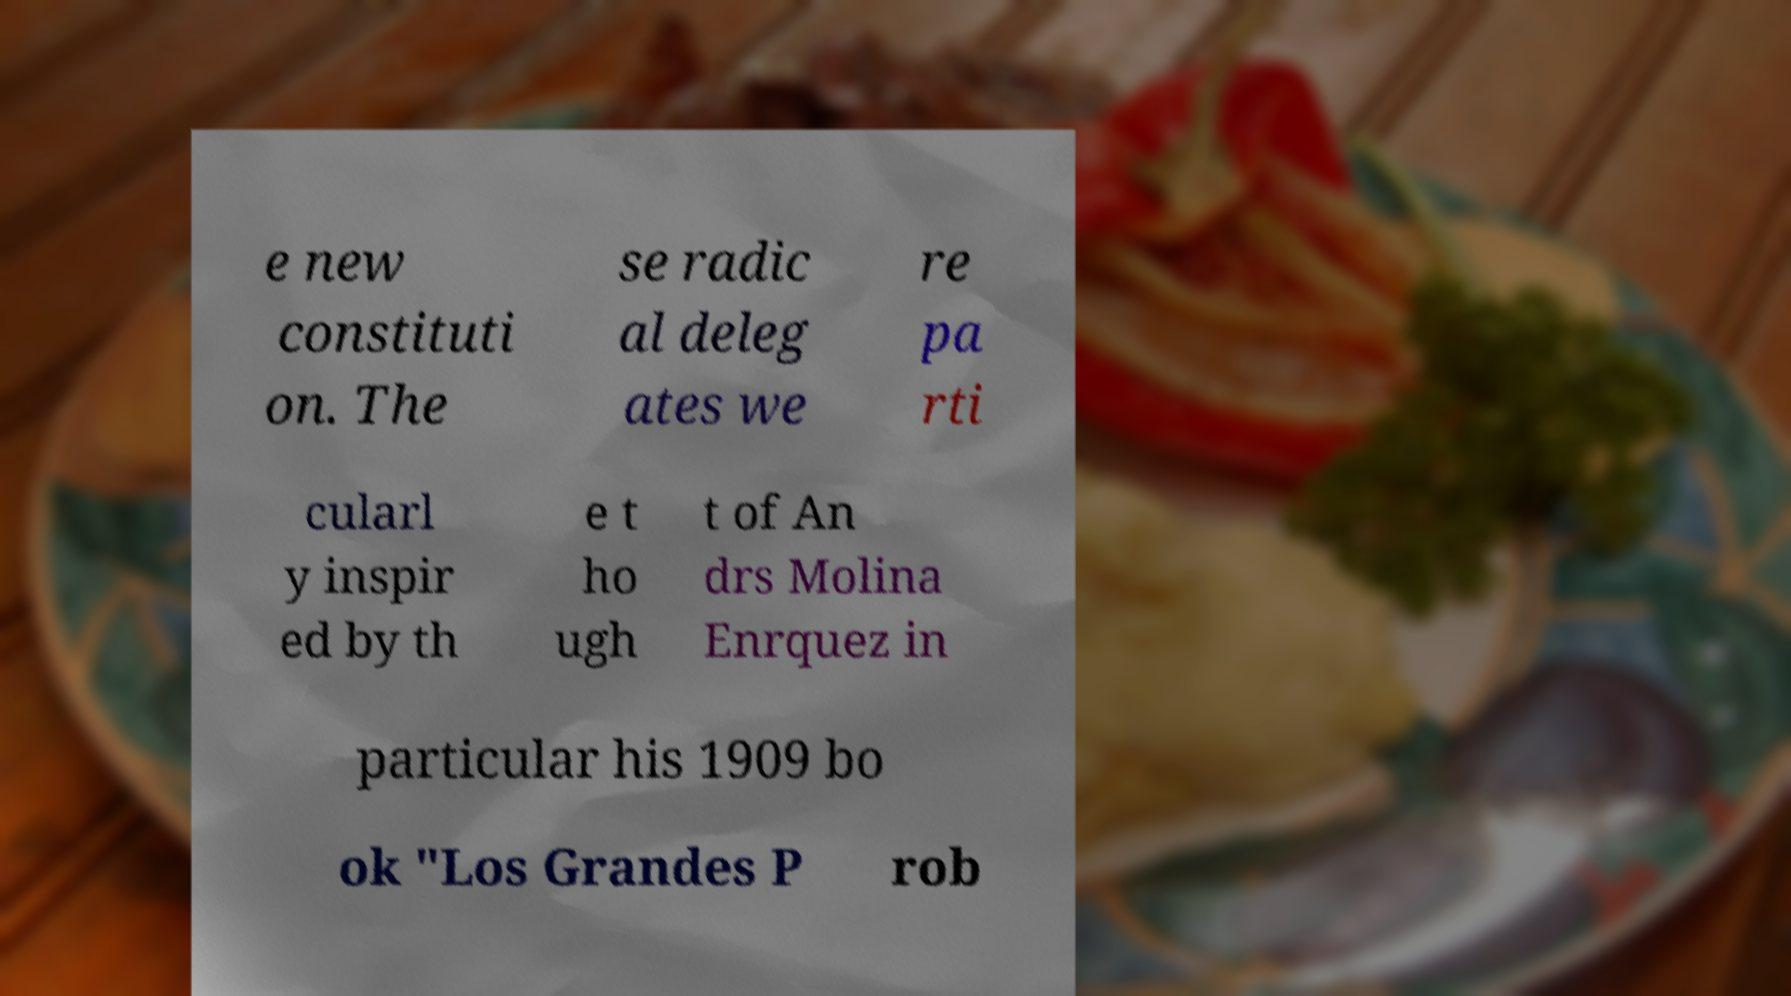For documentation purposes, I need the text within this image transcribed. Could you provide that? e new constituti on. The se radic al deleg ates we re pa rti cularl y inspir ed by th e t ho ugh t of An drs Molina Enrquez in particular his 1909 bo ok "Los Grandes P rob 